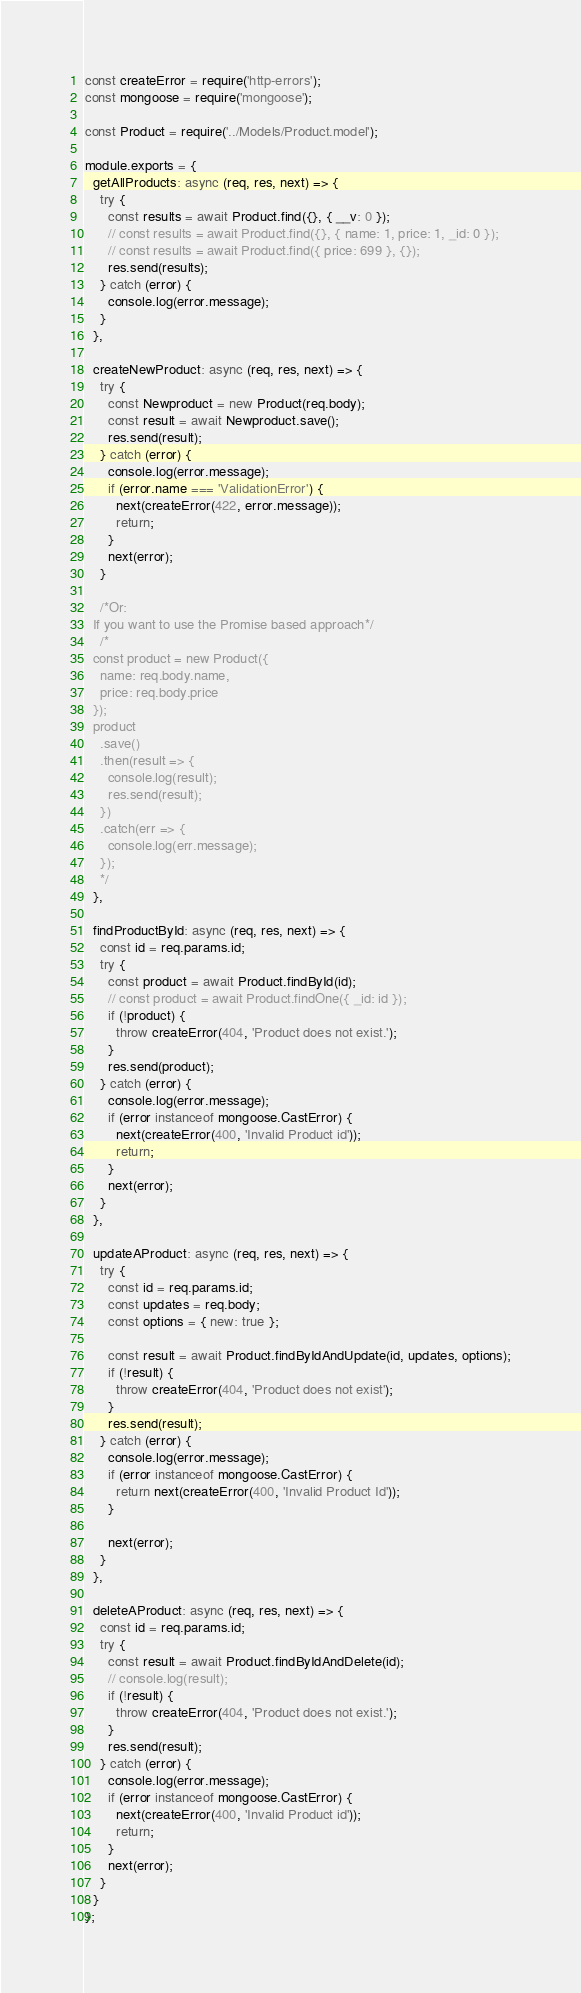Convert code to text. <code><loc_0><loc_0><loc_500><loc_500><_JavaScript_>const createError = require('http-errors');
const mongoose = require('mongoose');

const Product = require('../Models/Product.model');

module.exports = {
  getAllProducts: async (req, res, next) => {
    try {
      const results = await Product.find({}, { __v: 0 });
      // const results = await Product.find({}, { name: 1, price: 1, _id: 0 });
      // const results = await Product.find({ price: 699 }, {});
      res.send(results);
    } catch (error) {
      console.log(error.message);
    }
  },

  createNewProduct: async (req, res, next) => {
    try {
      const Newproduct = new Product(req.body);
      const result = await Newproduct.save();
      res.send(result);
    } catch (error) {
      console.log(error.message);
      if (error.name === 'ValidationError') {
        next(createError(422, error.message));
        return;
      }
      next(error);
    }

    /*Or:
  If you want to use the Promise based approach*/
    /*
  const product = new Product({
    name: req.body.name,
    price: req.body.price
  });
  product
    .save()
    .then(result => {
      console.log(result);
      res.send(result);
    })
    .catch(err => {
      console.log(err.message);
    }); 
    */
  },

  findProductById: async (req, res, next) => {
    const id = req.params.id;
    try {
      const product = await Product.findById(id);
      // const product = await Product.findOne({ _id: id });
      if (!product) {
        throw createError(404, 'Product does not exist.');
      }
      res.send(product);
    } catch (error) {
      console.log(error.message);
      if (error instanceof mongoose.CastError) {
        next(createError(400, 'Invalid Product id'));
        return;
      }
      next(error);
    }
  },

  updateAProduct: async (req, res, next) => {
    try {
      const id = req.params.id;
      const updates = req.body;
      const options = { new: true };

      const result = await Product.findByIdAndUpdate(id, updates, options);
      if (!result) {
        throw createError(404, 'Product does not exist');
      }
      res.send(result);
    } catch (error) {
      console.log(error.message);
      if (error instanceof mongoose.CastError) {
        return next(createError(400, 'Invalid Product Id'));
      }

      next(error);
    }
  },

  deleteAProduct: async (req, res, next) => {
    const id = req.params.id;
    try {
      const result = await Product.findByIdAndDelete(id);
      // console.log(result);
      if (!result) {
        throw createError(404, 'Product does not exist.');
      }
      res.send(result);
    } catch (error) {
      console.log(error.message);
      if (error instanceof mongoose.CastError) {
        next(createError(400, 'Invalid Product id'));
        return;
      }
      next(error);
    }
  }
};
</code> 